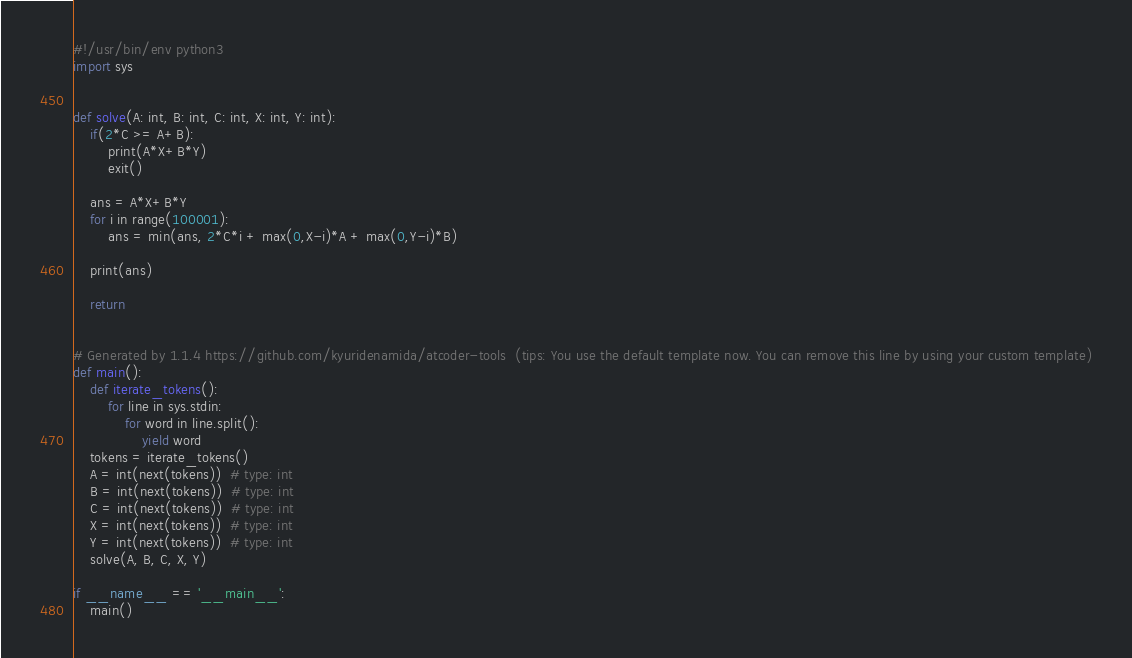<code> <loc_0><loc_0><loc_500><loc_500><_Python_>#!/usr/bin/env python3
import sys


def solve(A: int, B: int, C: int, X: int, Y: int):
    if(2*C >= A+B):
        print(A*X+B*Y)
        exit()

    ans = A*X+B*Y
    for i in range(100001):
        ans = min(ans, 2*C*i + max(0,X-i)*A + max(0,Y-i)*B)

    print(ans)

    return


# Generated by 1.1.4 https://github.com/kyuridenamida/atcoder-tools  (tips: You use the default template now. You can remove this line by using your custom template)
def main():
    def iterate_tokens():
        for line in sys.stdin:
            for word in line.split():
                yield word
    tokens = iterate_tokens()
    A = int(next(tokens))  # type: int
    B = int(next(tokens))  # type: int
    C = int(next(tokens))  # type: int
    X = int(next(tokens))  # type: int
    Y = int(next(tokens))  # type: int
    solve(A, B, C, X, Y)

if __name__ == '__main__':
    main()
</code> 